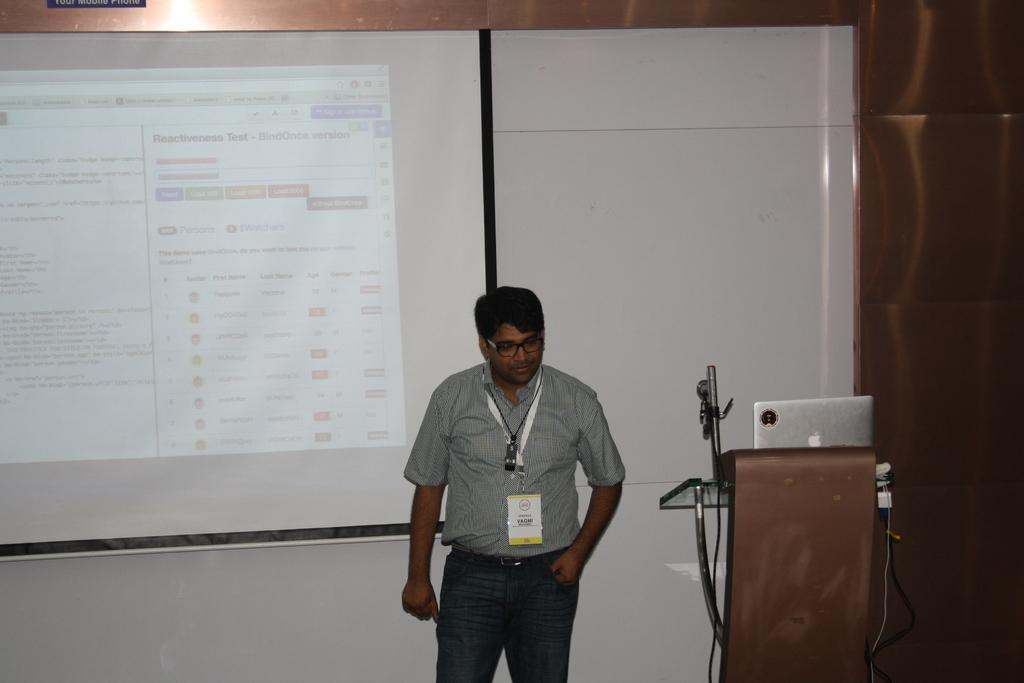What is the person in the image doing? The person is standing in front of a screen. What can be seen on the screen? The screen displays text. What is located on the right side of the image? There is a podium on the right side of the image. What items are present on the podium? Cables and wires, as well as a laptop, are visible on the podium. What type of bed is visible in the image? There is no bed present in the image. Can you describe the voice of the person in the image? The image does not provide any information about the person's voice. 